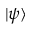Convert formula to latex. <formula><loc_0><loc_0><loc_500><loc_500>| \psi \rangle</formula> 